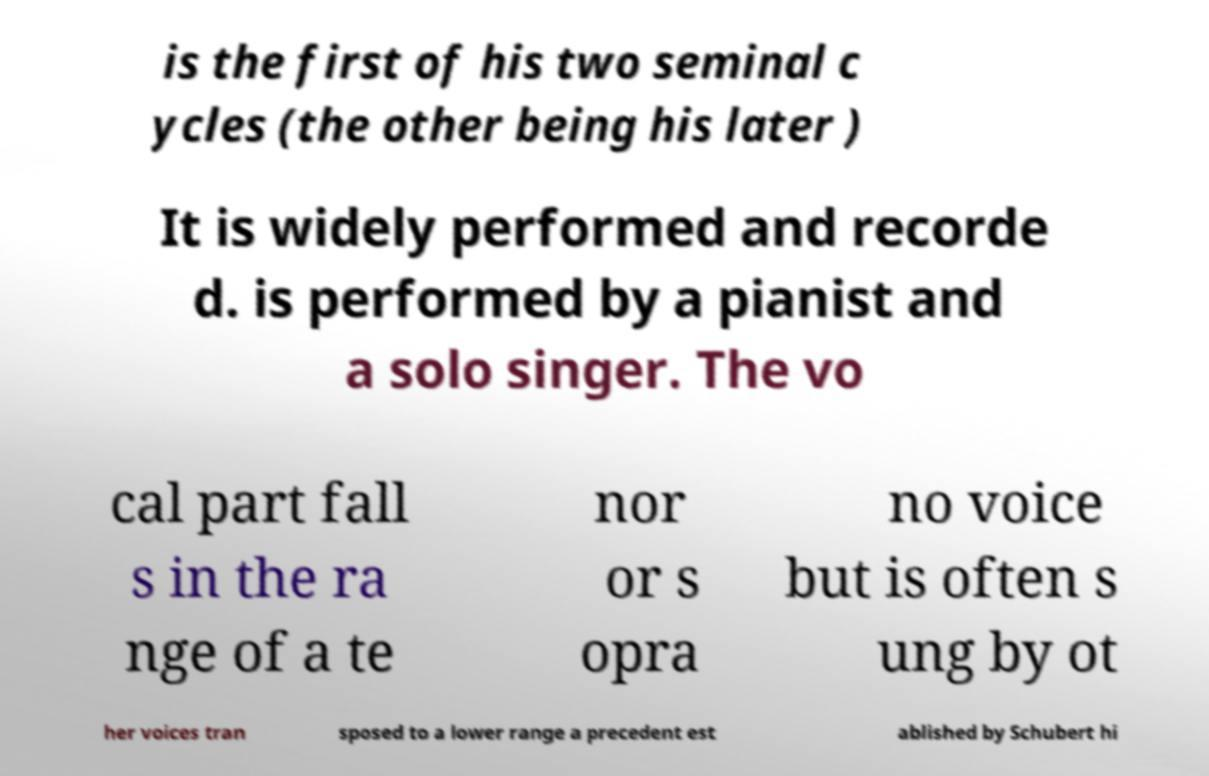For documentation purposes, I need the text within this image transcribed. Could you provide that? is the first of his two seminal c ycles (the other being his later ) It is widely performed and recorde d. is performed by a pianist and a solo singer. The vo cal part fall s in the ra nge of a te nor or s opra no voice but is often s ung by ot her voices tran sposed to a lower range a precedent est ablished by Schubert hi 